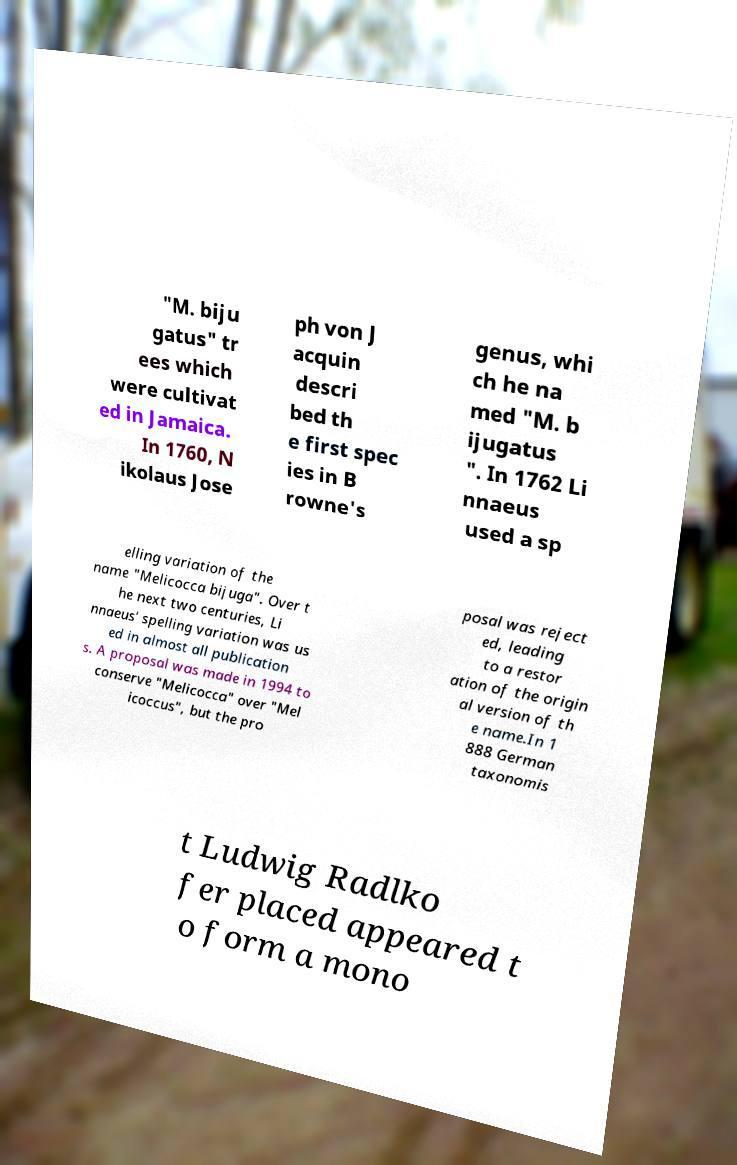Can you accurately transcribe the text from the provided image for me? "M. biju gatus" tr ees which were cultivat ed in Jamaica. In 1760, N ikolaus Jose ph von J acquin descri bed th e first spec ies in B rowne's genus, whi ch he na med "M. b ijugatus ". In 1762 Li nnaeus used a sp elling variation of the name "Melicocca bijuga". Over t he next two centuries, Li nnaeus' spelling variation was us ed in almost all publication s. A proposal was made in 1994 to conserve "Melicocca" over "Mel icoccus", but the pro posal was reject ed, leading to a restor ation of the origin al version of th e name.In 1 888 German taxonomis t Ludwig Radlko fer placed appeared t o form a mono 